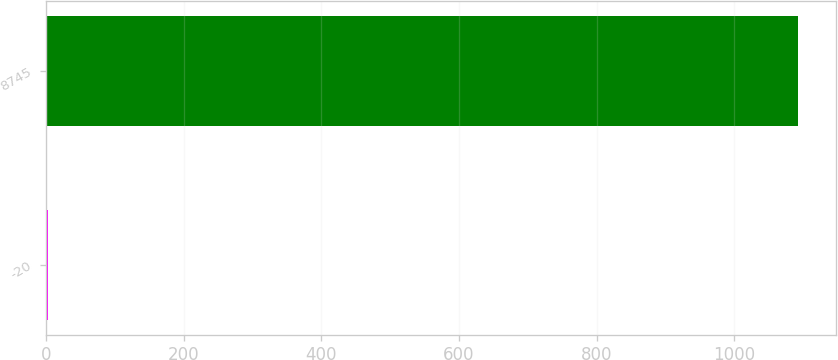Convert chart to OTSL. <chart><loc_0><loc_0><loc_500><loc_500><bar_chart><fcel>-20<fcel>8745<nl><fcel>3.35<fcel>1093.1<nl></chart> 